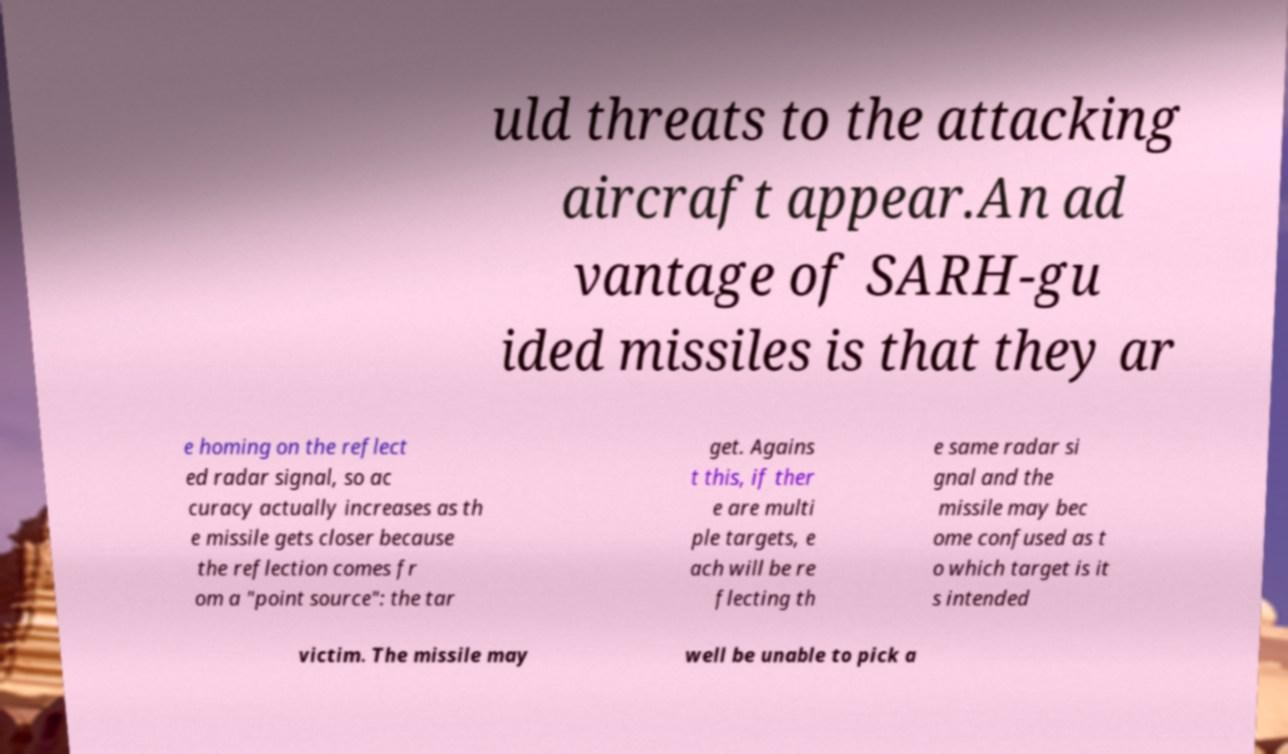There's text embedded in this image that I need extracted. Can you transcribe it verbatim? uld threats to the attacking aircraft appear.An ad vantage of SARH-gu ided missiles is that they ar e homing on the reflect ed radar signal, so ac curacy actually increases as th e missile gets closer because the reflection comes fr om a "point source": the tar get. Agains t this, if ther e are multi ple targets, e ach will be re flecting th e same radar si gnal and the missile may bec ome confused as t o which target is it s intended victim. The missile may well be unable to pick a 